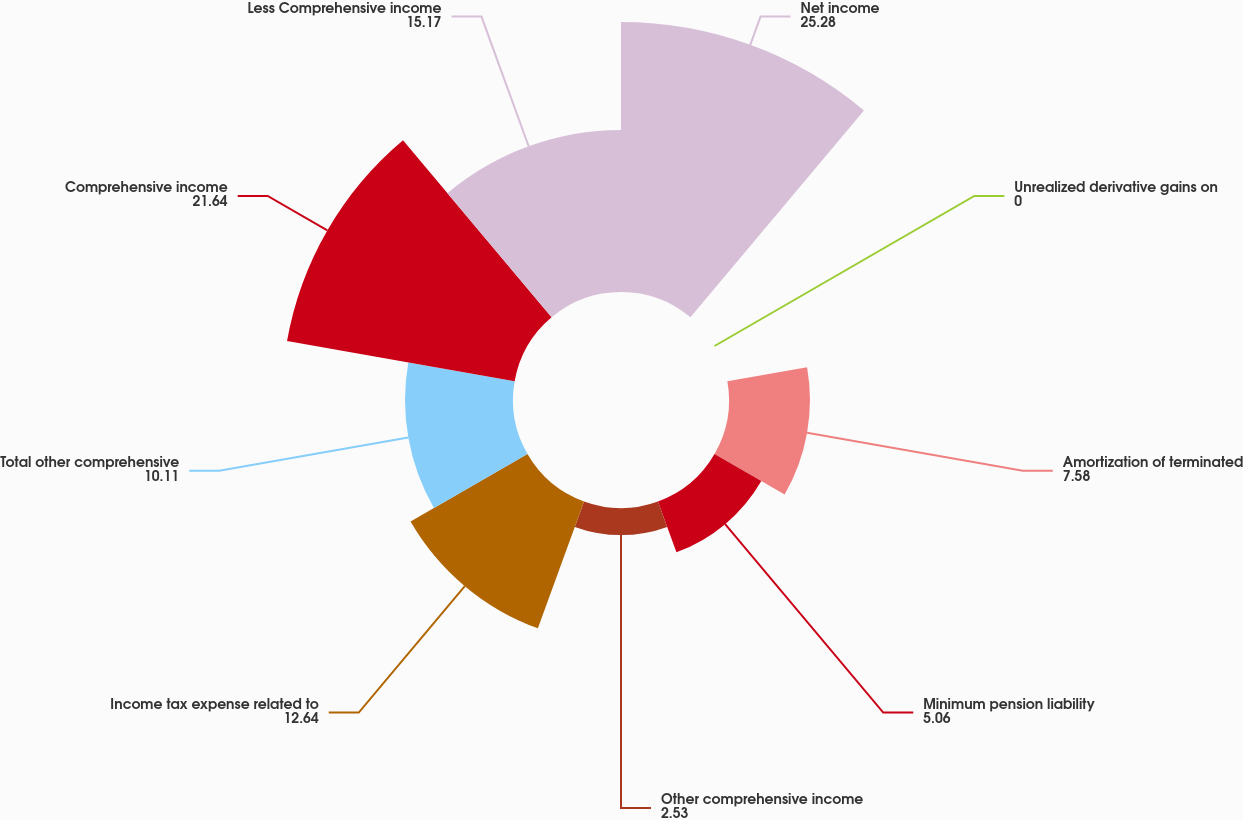<chart> <loc_0><loc_0><loc_500><loc_500><pie_chart><fcel>Net income<fcel>Unrealized derivative gains on<fcel>Amortization of terminated<fcel>Minimum pension liability<fcel>Other comprehensive income<fcel>Income tax expense related to<fcel>Total other comprehensive<fcel>Comprehensive income<fcel>Less Comprehensive income<nl><fcel>25.28%<fcel>0.0%<fcel>7.58%<fcel>5.06%<fcel>2.53%<fcel>12.64%<fcel>10.11%<fcel>21.64%<fcel>15.17%<nl></chart> 